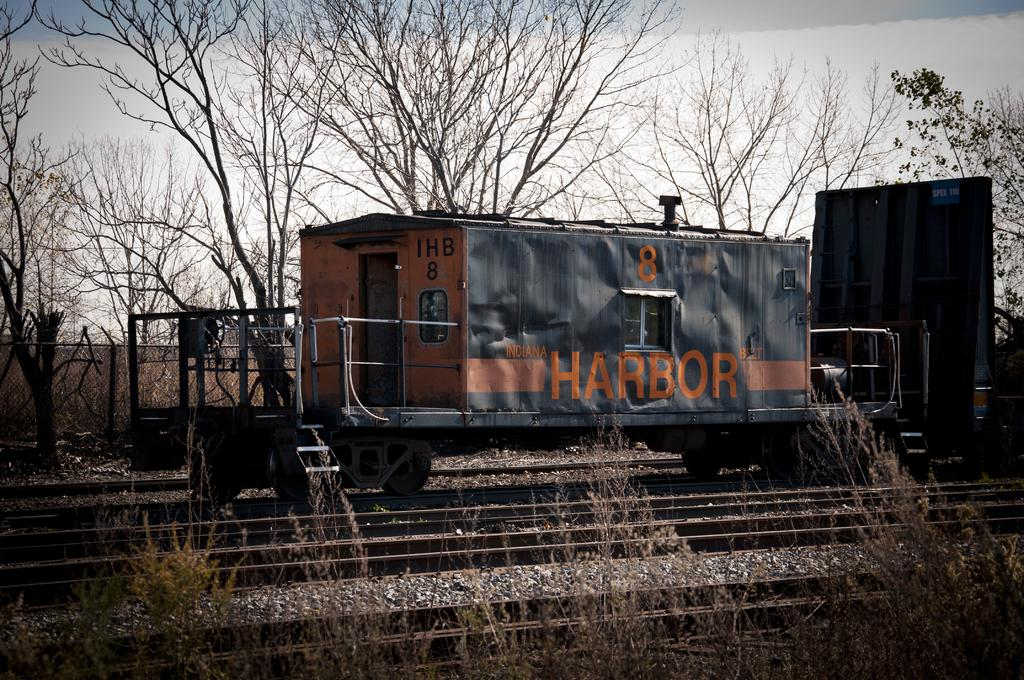What is the main subject of the image? There is a vehicle in the image. What can be seen in the background of the image? There are trees and the sky visible in the background of the image. How many pets are visible in the image? There are no pets present in the image. What is the amount of water visible in the image? There is no water present in the image. 